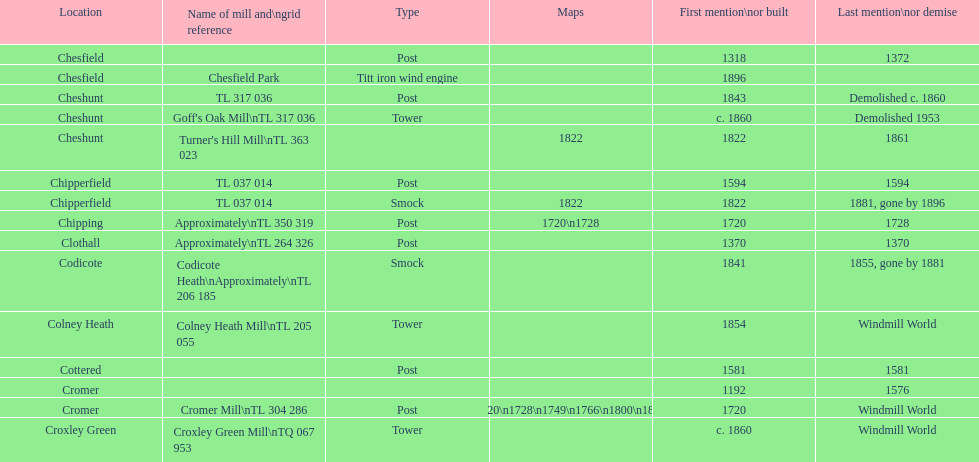How many locations have or had at least 2 windmills? 4. 